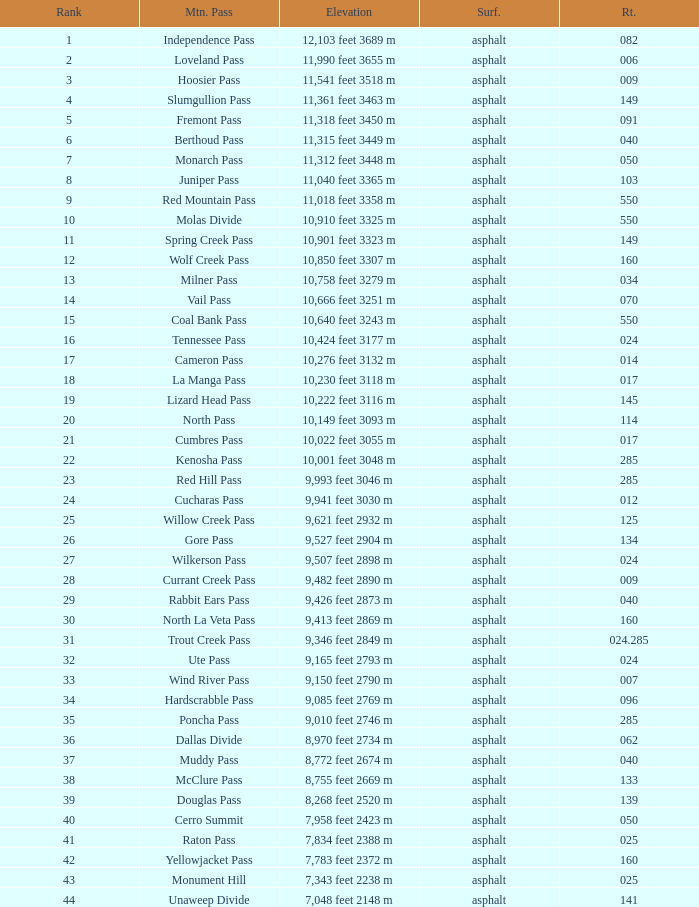What is the Elevation of the mountain on Route 62? 8,970 feet 2734 m. 